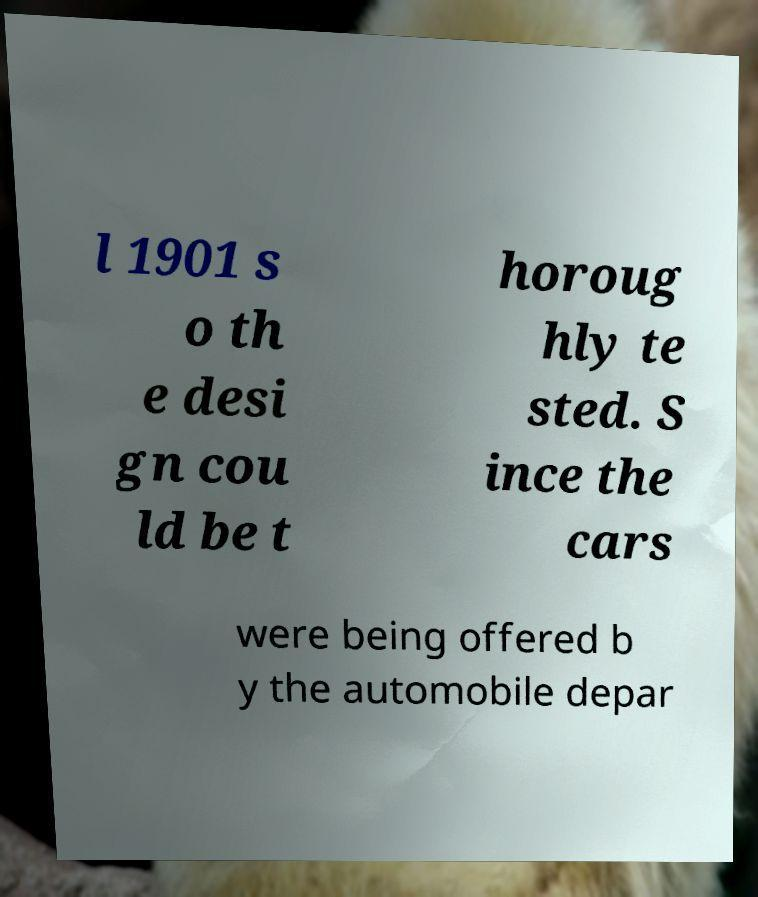Please read and relay the text visible in this image. What does it say? l 1901 s o th e desi gn cou ld be t horoug hly te sted. S ince the cars were being offered b y the automobile depar 